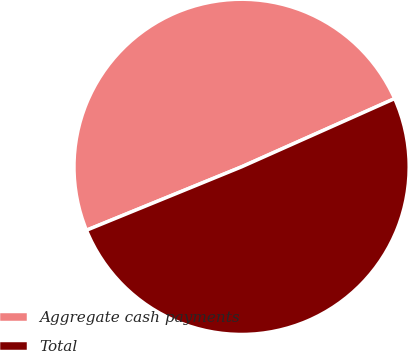Convert chart to OTSL. <chart><loc_0><loc_0><loc_500><loc_500><pie_chart><fcel>Aggregate cash payments<fcel>Total<nl><fcel>49.5%<fcel>50.5%<nl></chart> 